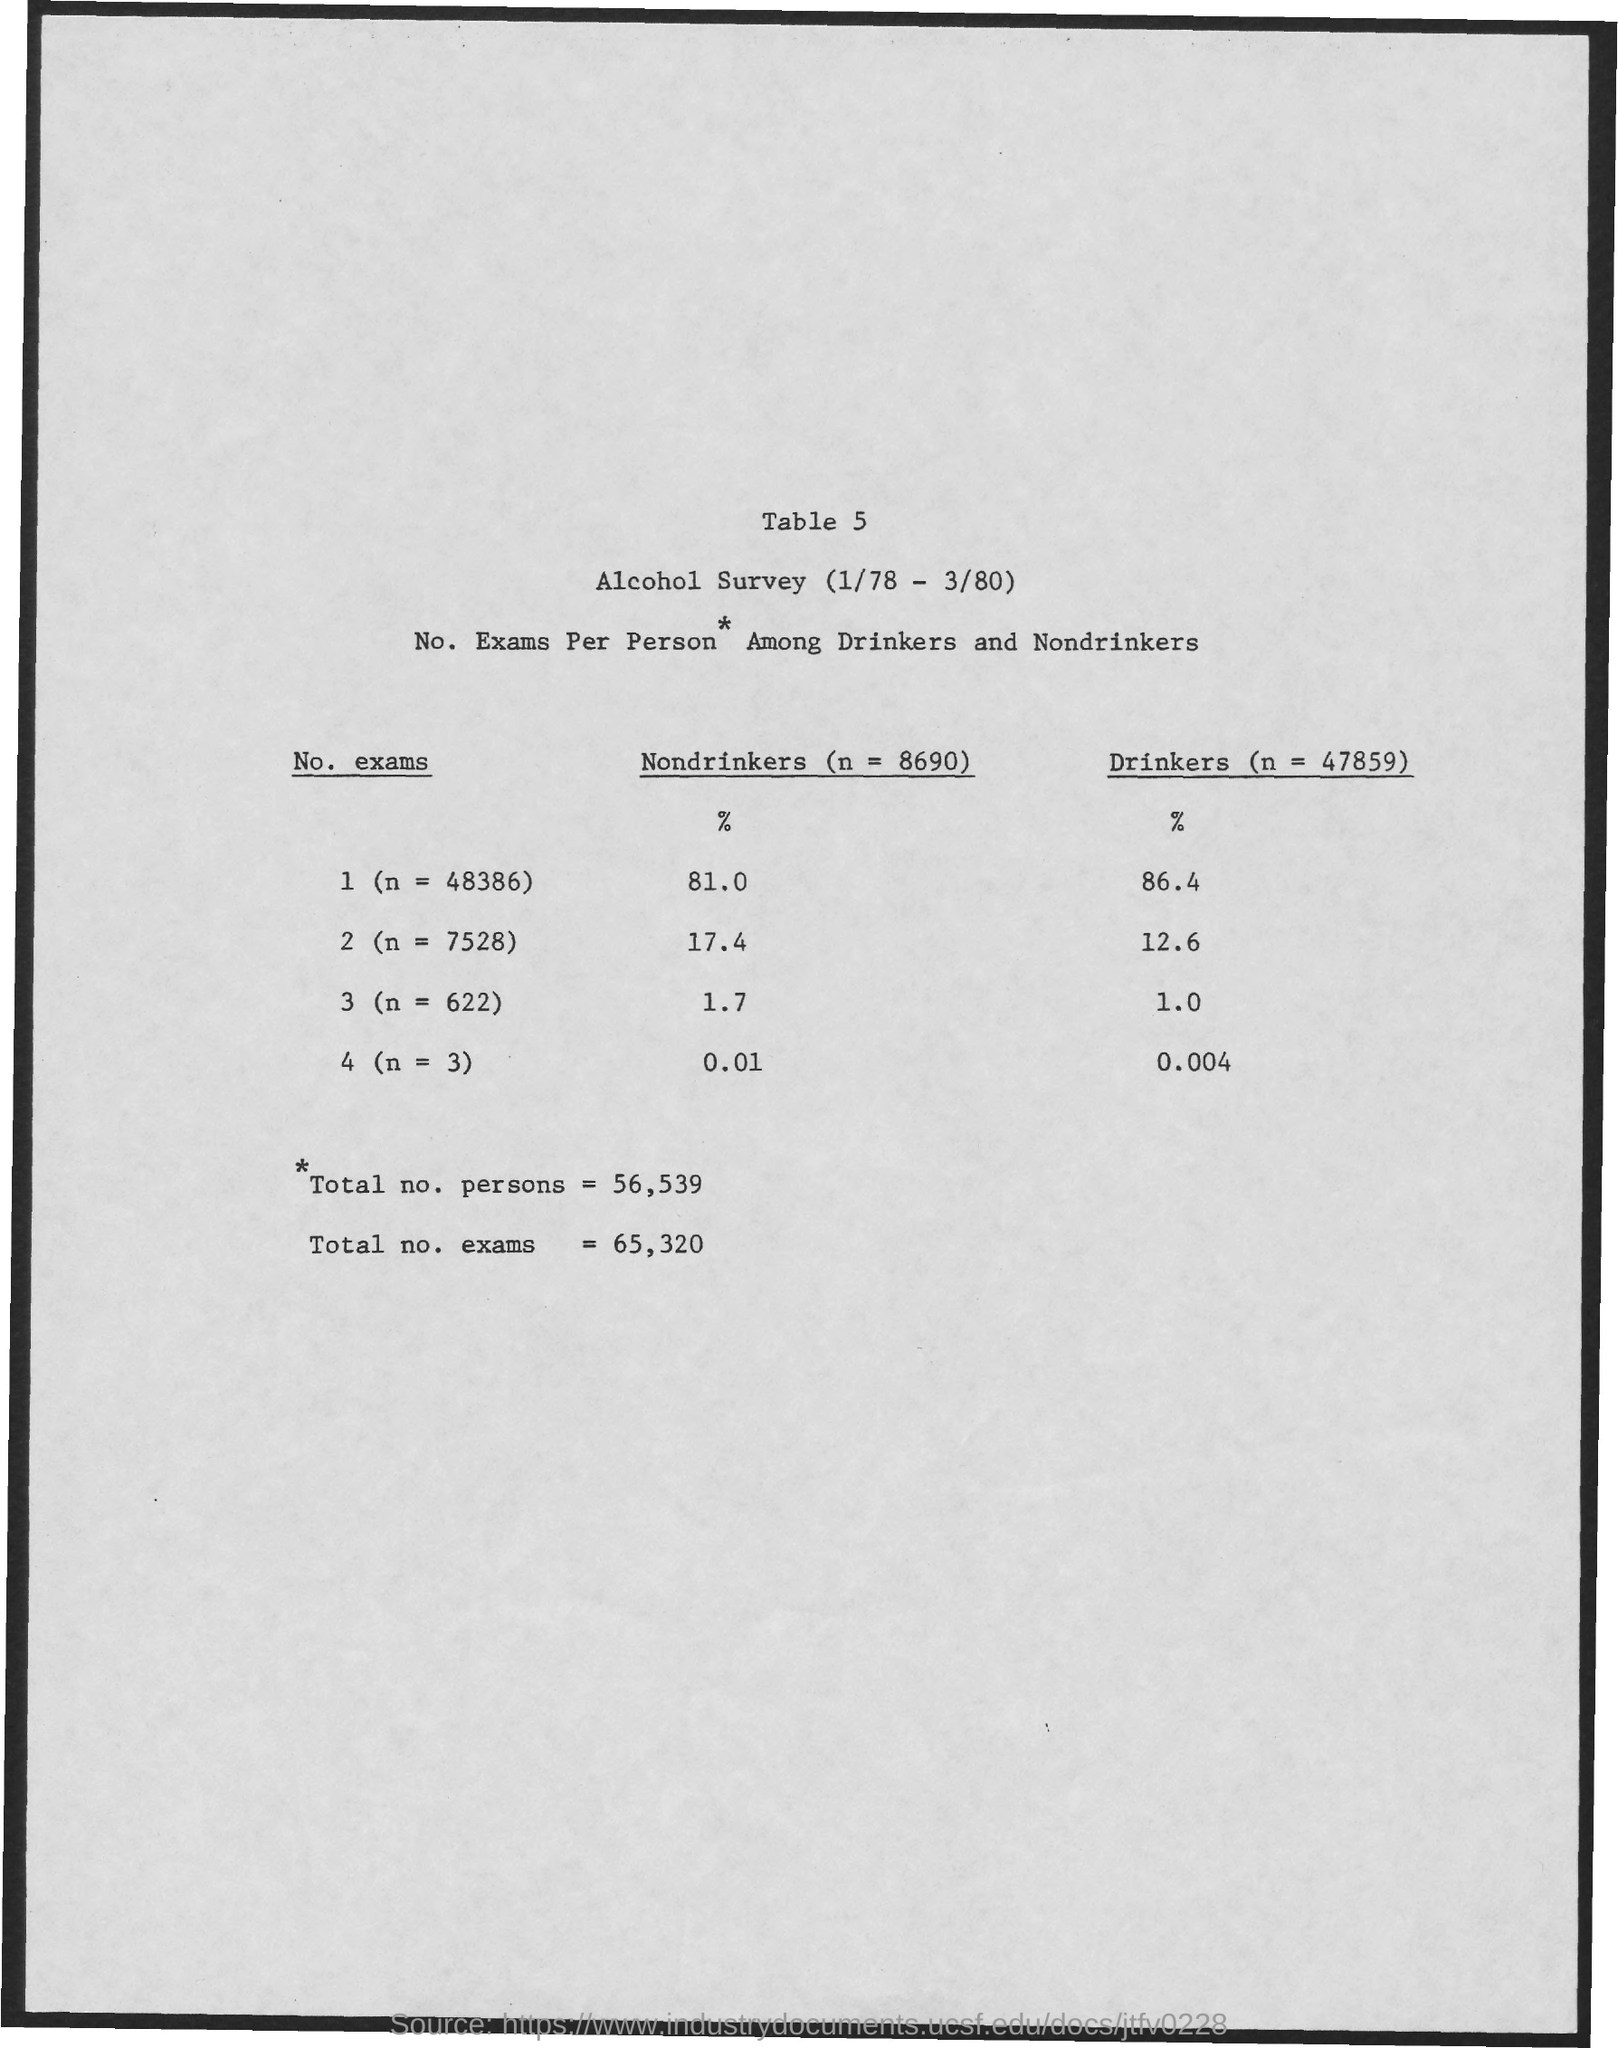What is the table number?
Offer a very short reply. Table 5. What is the total no. of persons?
Your response must be concise. 56,539. What is the total no.of exams?
Offer a terse response. 65,320. What is the percentage of nondrinkers for n=48386?
Your response must be concise. 81.0. What is the percentage of drinkers for n=3?
Keep it short and to the point. 0.004. The percentage of drinkers are highest for what value of "n"?
Provide a succinct answer. 48386. The percentage of drinkers are lowest for what value of "n"?
Ensure brevity in your answer.  3. 